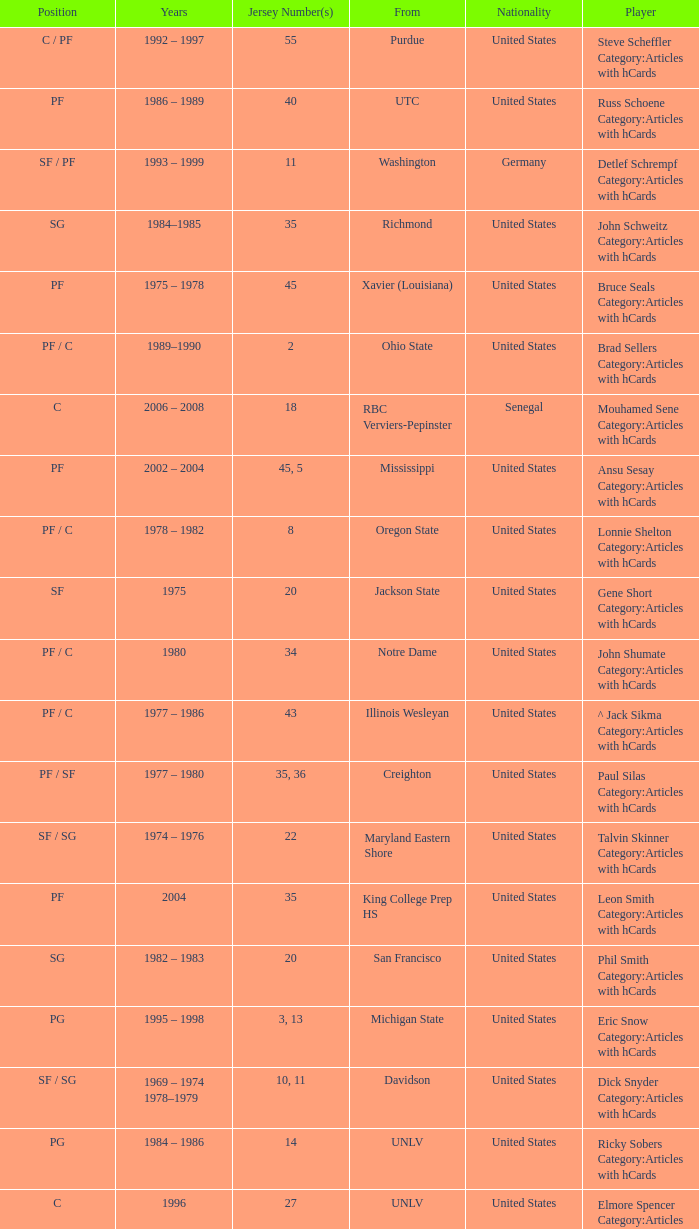What position does the player with jersey number 22 play? SF / SG. 